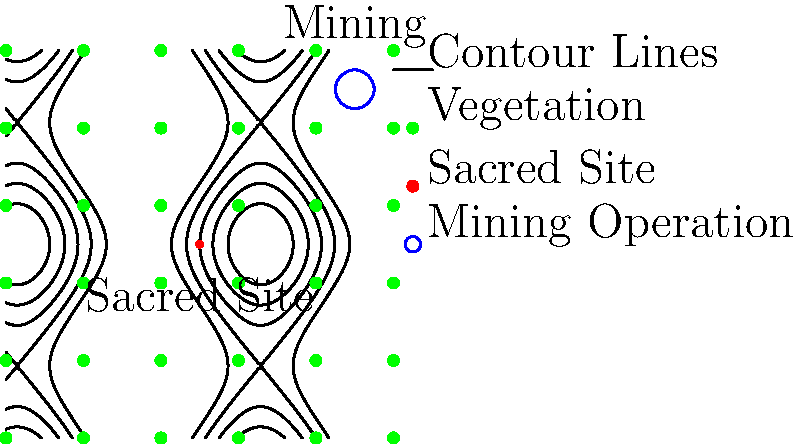Based on the contour map and vegetation diagram provided, which erosion control method would be most appropriate to protect the sacred indigenous site from potential runoff from the nearby mining operation while minimizing disruption to the existing landscape? To determine the most appropriate erosion control method, we need to analyze the given information step-by-step:

1. Contour lines: The contour lines indicate that the terrain slopes downward from the mining operation (top right) towards the sacred site (center). This suggests that runoff from the mining site could potentially flow towards the sacred site.

2. Vegetation: The green dots represent existing vegetation, which is evenly distributed across the area. This vegetation provides some natural erosion control but may not be sufficient given the potential mining runoff.

3. Sacred site location: The sacred site is located at the center of the map, in a relatively low-lying area based on the contour lines.

4. Mining operation: The mining operation is situated at a higher elevation compared to the sacred site, increasing the risk of runoff.

5. Minimal disruption requirement: The chosen method should preserve the existing landscape as much as possible, respecting the cultural significance of the area.

Considering these factors, the most appropriate erosion control method would be the installation of vegetated buffer strips. This method involves:

a) Creating strips of dense, native vegetation between the mining operation and the sacred site.
b) Following the contour lines to maximize effectiveness in slowing and filtering runoff.
c) Utilizing existing vegetation patterns to minimize disruption to the landscape.
d) Providing additional benefits such as habitat creation and visual screening.

Vegetated buffer strips would effectively slow down and filter runoff from the mining operation, protecting the sacred site while maintaining the natural character of the area. This method aligns with indigenous land management practices and respects the cultural significance of the site.
Answer: Vegetated buffer strips 